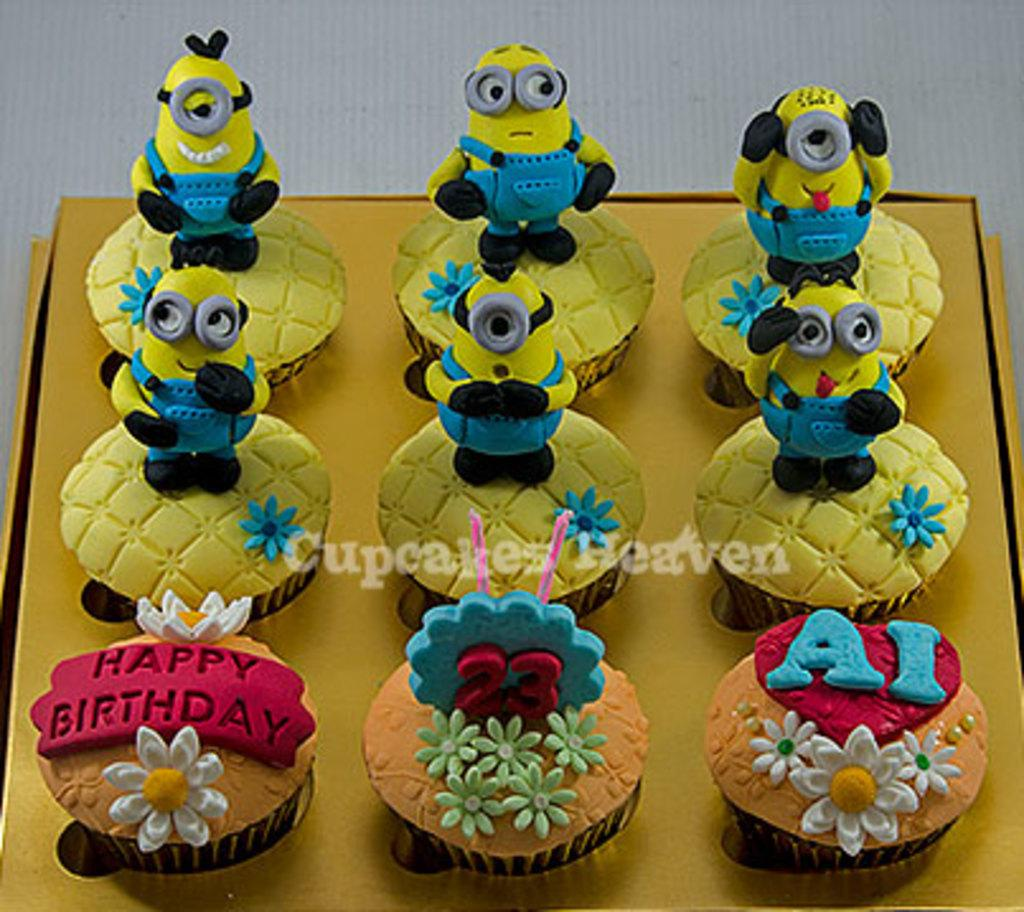What color is the surface on which the muffins are placed in the image? There is a yellow surface in the image. What is placed on the yellow surface? There are muffins on the yellow surface. Are there any decorations on the muffins? Yes, there are flowers on three of the muffins. What is positioned above the middle muffin? There are candles above the middle muffin. What characters are above the six muffins? There are minions above the six muffins. What type of leather is used for the skirt in the image? There is no skirt or leather present in the image. 